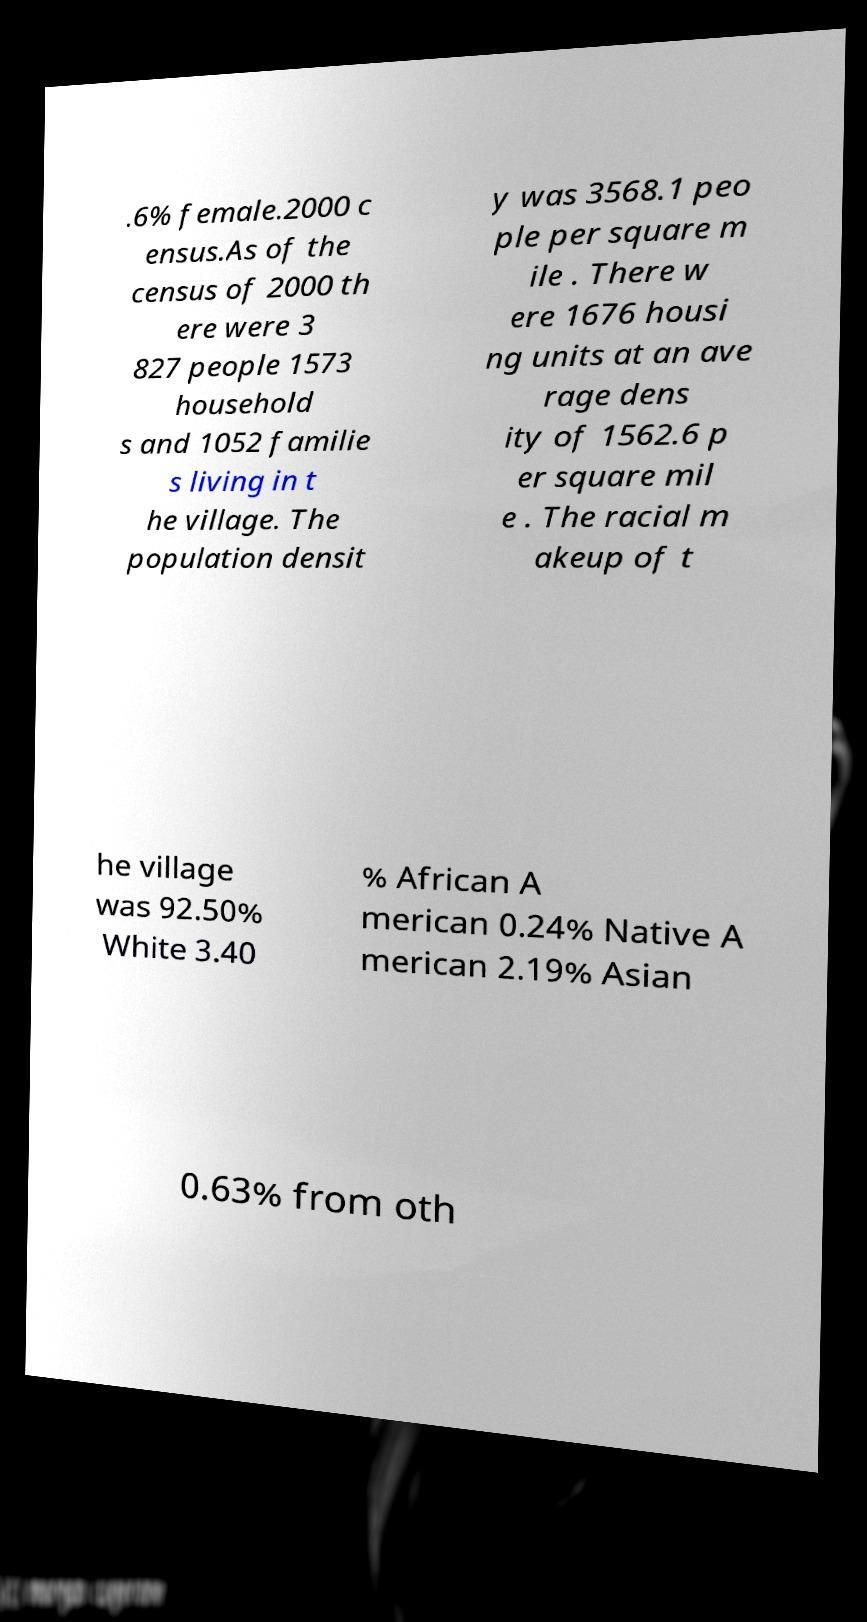Please read and relay the text visible in this image. What does it say? .6% female.2000 c ensus.As of the census of 2000 th ere were 3 827 people 1573 household s and 1052 familie s living in t he village. The population densit y was 3568.1 peo ple per square m ile . There w ere 1676 housi ng units at an ave rage dens ity of 1562.6 p er square mil e . The racial m akeup of t he village was 92.50% White 3.40 % African A merican 0.24% Native A merican 2.19% Asian 0.63% from oth 